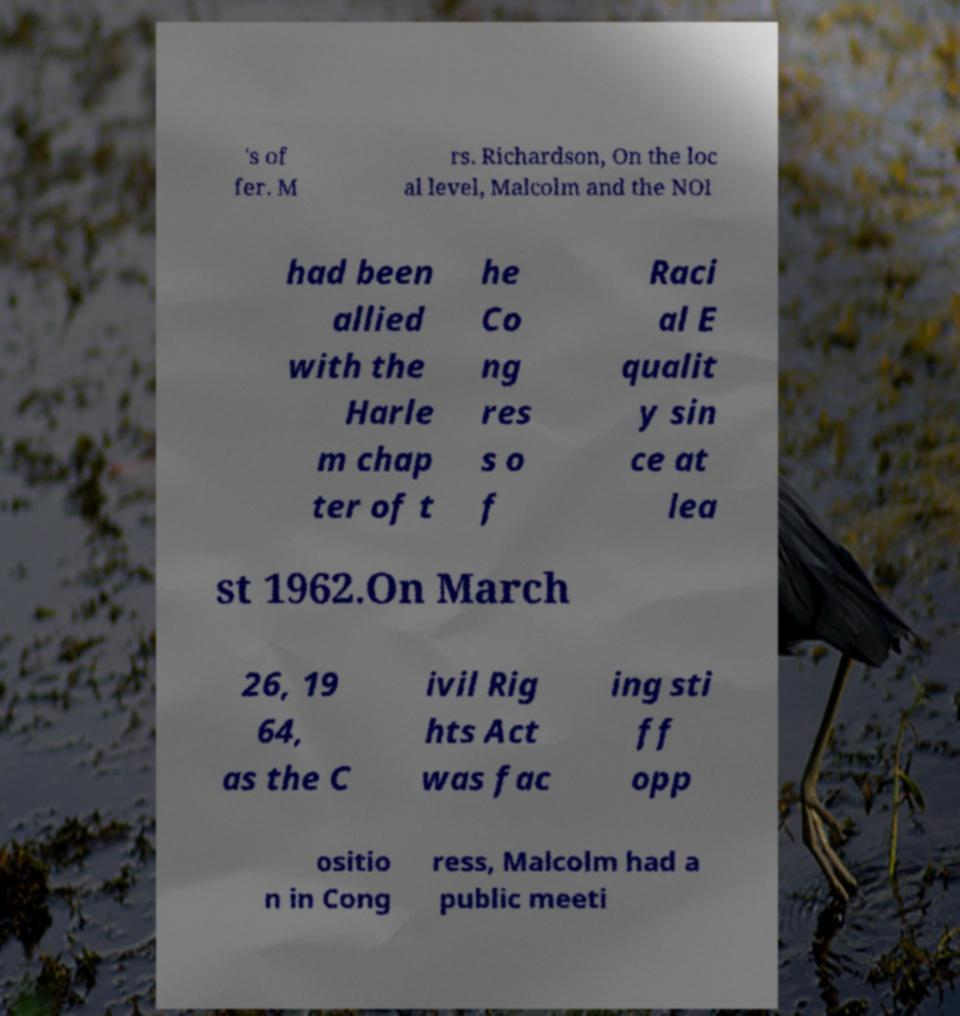Could you extract and type out the text from this image? 's of fer. M rs. Richardson, On the loc al level, Malcolm and the NOI had been allied with the Harle m chap ter of t he Co ng res s o f Raci al E qualit y sin ce at lea st 1962.On March 26, 19 64, as the C ivil Rig hts Act was fac ing sti ff opp ositio n in Cong ress, Malcolm had a public meeti 